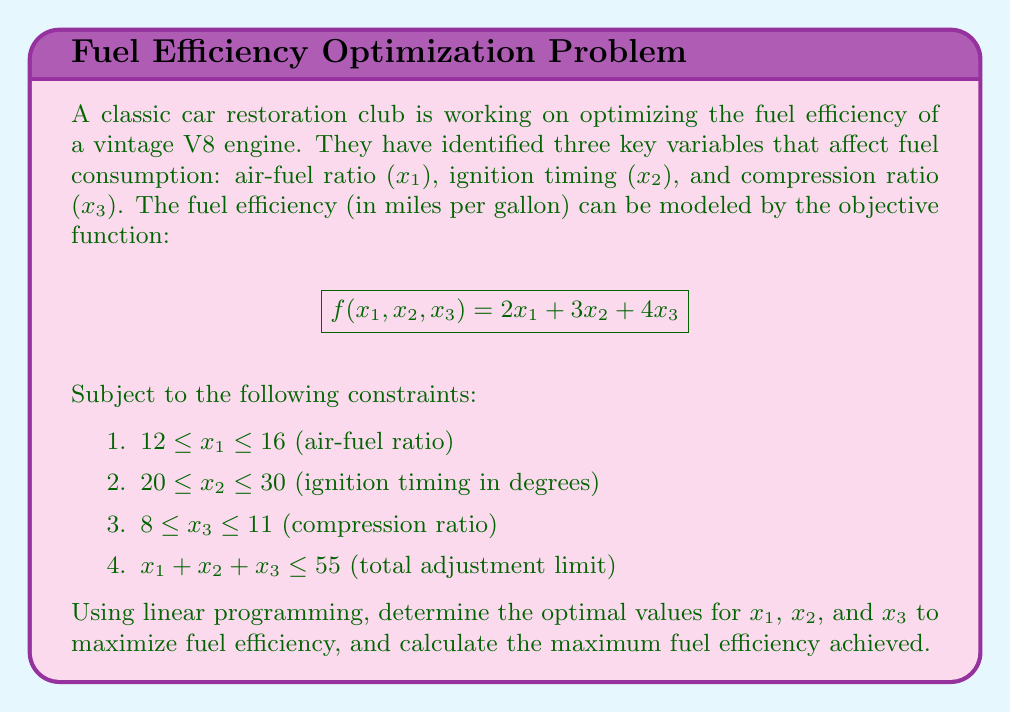Solve this math problem. To solve this linear programming problem, we'll use the simplex method:

Step 1: Convert inequalities to equations by introducing slack variables.
$$x_1 + s_1 = 16$$
$$x_2 + s_2 = 30$$
$$x_3 + s_3 = 11$$
$$x_1 + x_2 + x_3 + s_4 = 55$$

Step 2: Set up the initial tableau.
$$\begin{array}{c|cccc|cccc|c}
 & x_1 & x_2 & x_3 & z & s_1 & s_2 & s_3 & s_4 & RHS \\
\hline
s_1 & 1 & 0 & 0 & 0 & 1 & 0 & 0 & 0 & 16 \\
s_2 & 0 & 1 & 0 & 0 & 0 & 1 & 0 & 0 & 30 \\
s_3 & 0 & 0 & 1 & 0 & 0 & 0 & 1 & 0 & 11 \\
s_4 & 1 & 1 & 1 & 0 & 0 & 0 & 0 & 1 & 55 \\
\hline
z & -2 & -3 & -4 & 1 & 0 & 0 & 0 & 0 & 0
\end{array}$$

Step 3: Identify the pivot column (most negative in z-row) and pivot row (smallest positive ratio of RHS to pivot column).
Pivot column: $x_3$ (-4)
Pivot row: $s_3$ (11/1 = 11)

Step 4: Perform row operations to make the pivot element 1 and other elements in the column 0.

Step 5: Repeat steps 3-4 until no negative values remain in the z-row.

Final tableau:
$$\begin{array}{c|cccc|cccc|c}
 & x_1 & x_2 & x_3 & z & s_1 & s_2 & s_3 & s_4 & RHS \\
\hline
x_1 & 1 & 0 & 0 & 0 & 1 & 0 & 0 & 0 & 16 \\
x_2 & 0 & 1 & 0 & 0 & 0 & 1 & 0 & 0 & 28 \\
x_3 & 0 & 0 & 1 & 0 & 0 & 0 & 1 & 0 & 11 \\
s_4 & 0 & 0 & 0 & 0 & -1 & -1 & -1 & 1 & 0 \\
\hline
z & 0 & 0 & 0 & 1 & 2 & 3 & 4 & 0 & 154
\end{array}$$

Step 6: Read the optimal solution from the final tableau.
$x_1 = 16$, $x_2 = 28$, $x_3 = 11$
Maximum fuel efficiency: 154 miles per gallon
Answer: $x_1 = 16$, $x_2 = 28$, $x_3 = 11$; Max efficiency: 154 mpg 